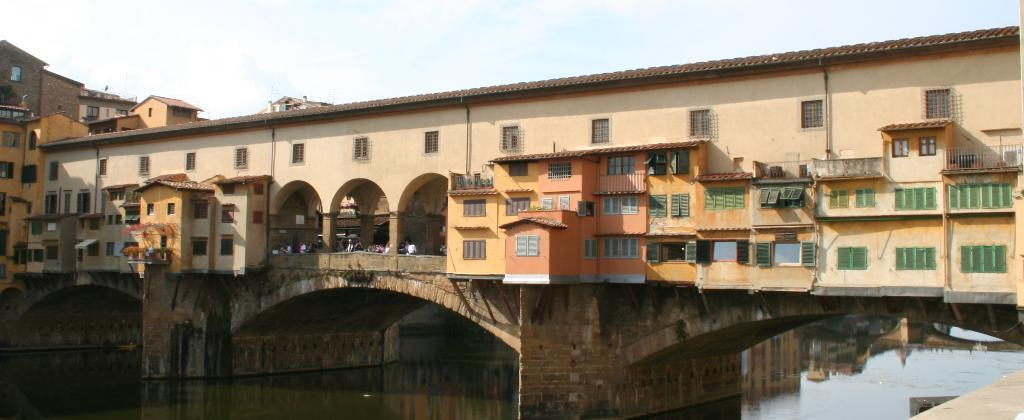What type of structure is visible in the image? There is a building in the image. Where is the building located? The building is on the water. What is visible at the top of the image? The sky is visible at the top of the image. What type of writing can be seen on the glass in the image? There is no glass or writing present in the image. 